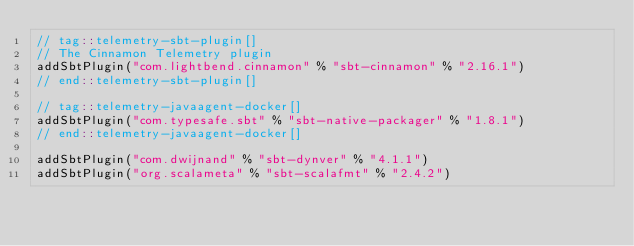Convert code to text. <code><loc_0><loc_0><loc_500><loc_500><_Scala_>// tag::telemetry-sbt-plugin[]
// The Cinnamon Telemetry plugin
addSbtPlugin("com.lightbend.cinnamon" % "sbt-cinnamon" % "2.16.1")
// end::telemetry-sbt-plugin[]

// tag::telemetry-javaagent-docker[]
addSbtPlugin("com.typesafe.sbt" % "sbt-native-packager" % "1.8.1")
// end::telemetry-javaagent-docker[]

addSbtPlugin("com.dwijnand" % "sbt-dynver" % "4.1.1")
addSbtPlugin("org.scalameta" % "sbt-scalafmt" % "2.4.2")</code> 